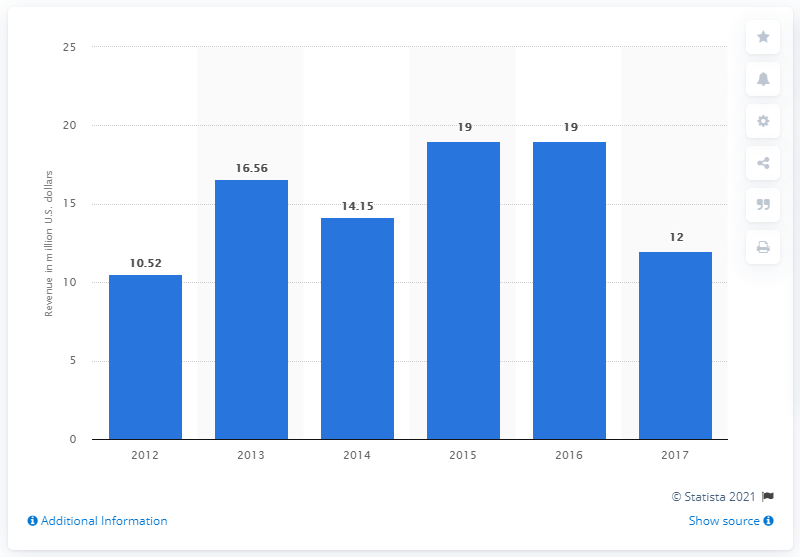Draw attention to some important aspects in this diagram. In 2017, Evo Fitness generated a significant amount of revenue. 